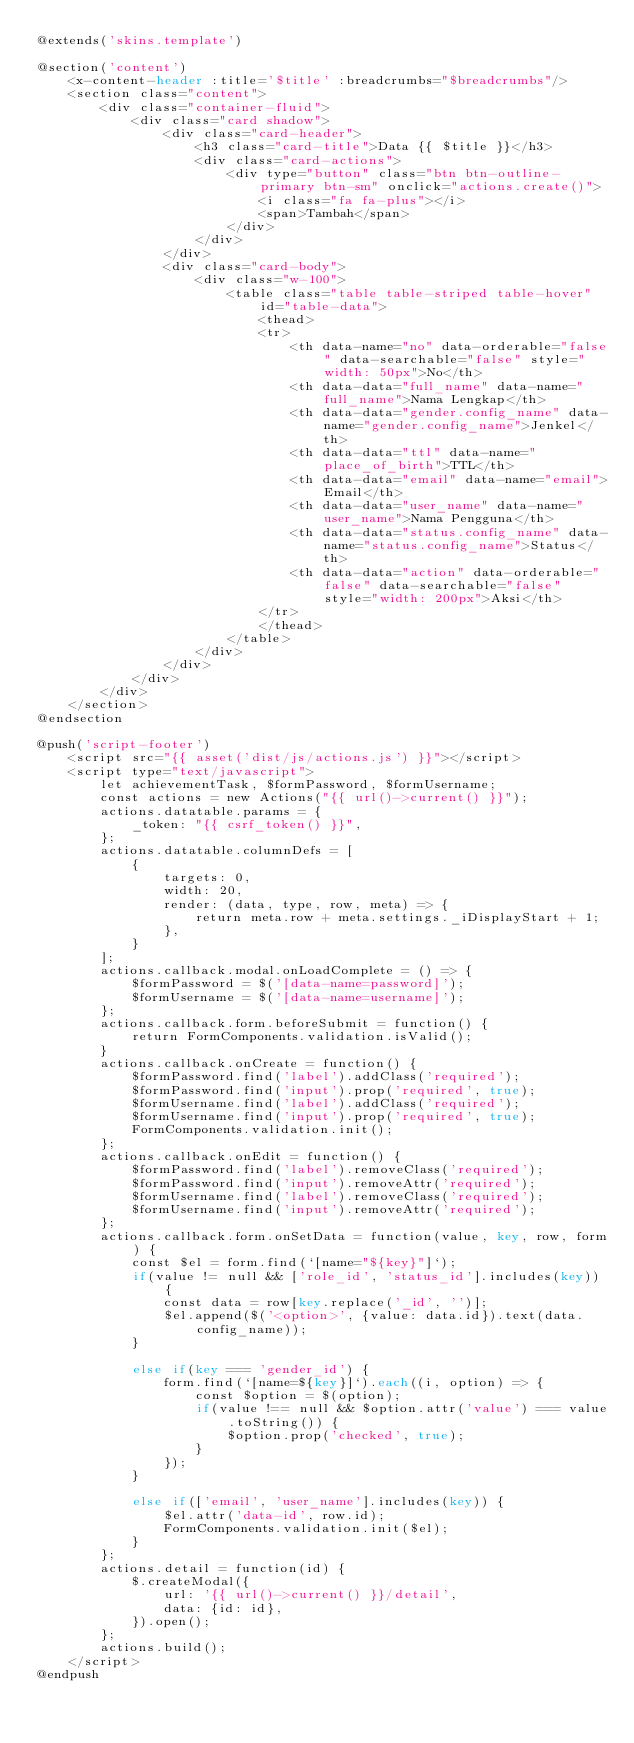<code> <loc_0><loc_0><loc_500><loc_500><_PHP_>@extends('skins.template')

@section('content')
    <x-content-header :title='$title' :breadcrumbs="$breadcrumbs"/>
    <section class="content">
        <div class="container-fluid">
            <div class="card shadow">
                <div class="card-header">
                    <h3 class="card-title">Data {{ $title }}</h3>
                    <div class="card-actions">
                        <div type="button" class="btn btn-outline-primary btn-sm" onclick="actions.create()">
                            <i class="fa fa-plus"></i>
                            <span>Tambah</span>
                        </div>
                    </div>
                </div>
                <div class="card-body">
                    <div class="w-100">
                        <table class="table table-striped table-hover" id="table-data">
                            <thead>
                            <tr>
                                <th data-name="no" data-orderable="false" data-searchable="false" style="width: 50px">No</th>
                                <th data-data="full_name" data-name="full_name">Nama Lengkap</th>
                                <th data-data="gender.config_name" data-name="gender.config_name">Jenkel</th>
                                <th data-data="ttl" data-name="place_of_birth">TTL</th>
                                <th data-data="email" data-name="email">Email</th>
                                <th data-data="user_name" data-name="user_name">Nama Pengguna</th>
                                <th data-data="status.config_name" data-name="status.config_name">Status</th>
                                <th data-data="action" data-orderable="false" data-searchable="false" style="width: 200px">Aksi</th>
                            </tr>
                            </thead>
                        </table>
                    </div>
                </div>
            </div>
        </div>
    </section>
@endsection

@push('script-footer')
    <script src="{{ asset('dist/js/actions.js') }}"></script>
    <script type="text/javascript">
        let achievementTask, $formPassword, $formUsername;
        const actions = new Actions("{{ url()->current() }}");
        actions.datatable.params = {
            _token: "{{ csrf_token() }}",
        };
        actions.datatable.columnDefs = [
            {
                targets: 0,
                width: 20,
                render: (data, type, row, meta) => {
                    return meta.row + meta.settings._iDisplayStart + 1;
                },
            }
        ];
        actions.callback.modal.onLoadComplete = () => {
            $formPassword = $('[data-name=password]');
            $formUsername = $('[data-name=username]');
        };
        actions.callback.form.beforeSubmit = function() {
            return FormComponents.validation.isValid();
        }
        actions.callback.onCreate = function() {
            $formPassword.find('label').addClass('required');
            $formPassword.find('input').prop('required', true);
            $formUsername.find('label').addClass('required');
            $formUsername.find('input').prop('required', true);
            FormComponents.validation.init();
        };
        actions.callback.onEdit = function() {
            $formPassword.find('label').removeClass('required');
            $formPassword.find('input').removeAttr('required');
            $formUsername.find('label').removeClass('required');
            $formUsername.find('input').removeAttr('required');
        };
        actions.callback.form.onSetData = function(value, key, row, form) {
            const $el = form.find(`[name="${key}"]`);
            if(value != null && ['role_id', 'status_id'].includes(key)) {
                const data = row[key.replace('_id', '')];
                $el.append($('<option>', {value: data.id}).text(data.config_name));
            }

            else if(key === 'gender_id') {
                form.find(`[name=${key}]`).each((i, option) => {
                    const $option = $(option);
                    if(value !== null && $option.attr('value') === value.toString()) {
                        $option.prop('checked', true);
                    }
                });
            }

            else if(['email', 'user_name'].includes(key)) {
                $el.attr('data-id', row.id);
                FormComponents.validation.init($el);
            }
        };
        actions.detail = function(id) {
            $.createModal({
                url: '{{ url()->current() }}/detail',
                data: {id: id},
            }).open();
        };
        actions.build();
    </script>
@endpush
</code> 